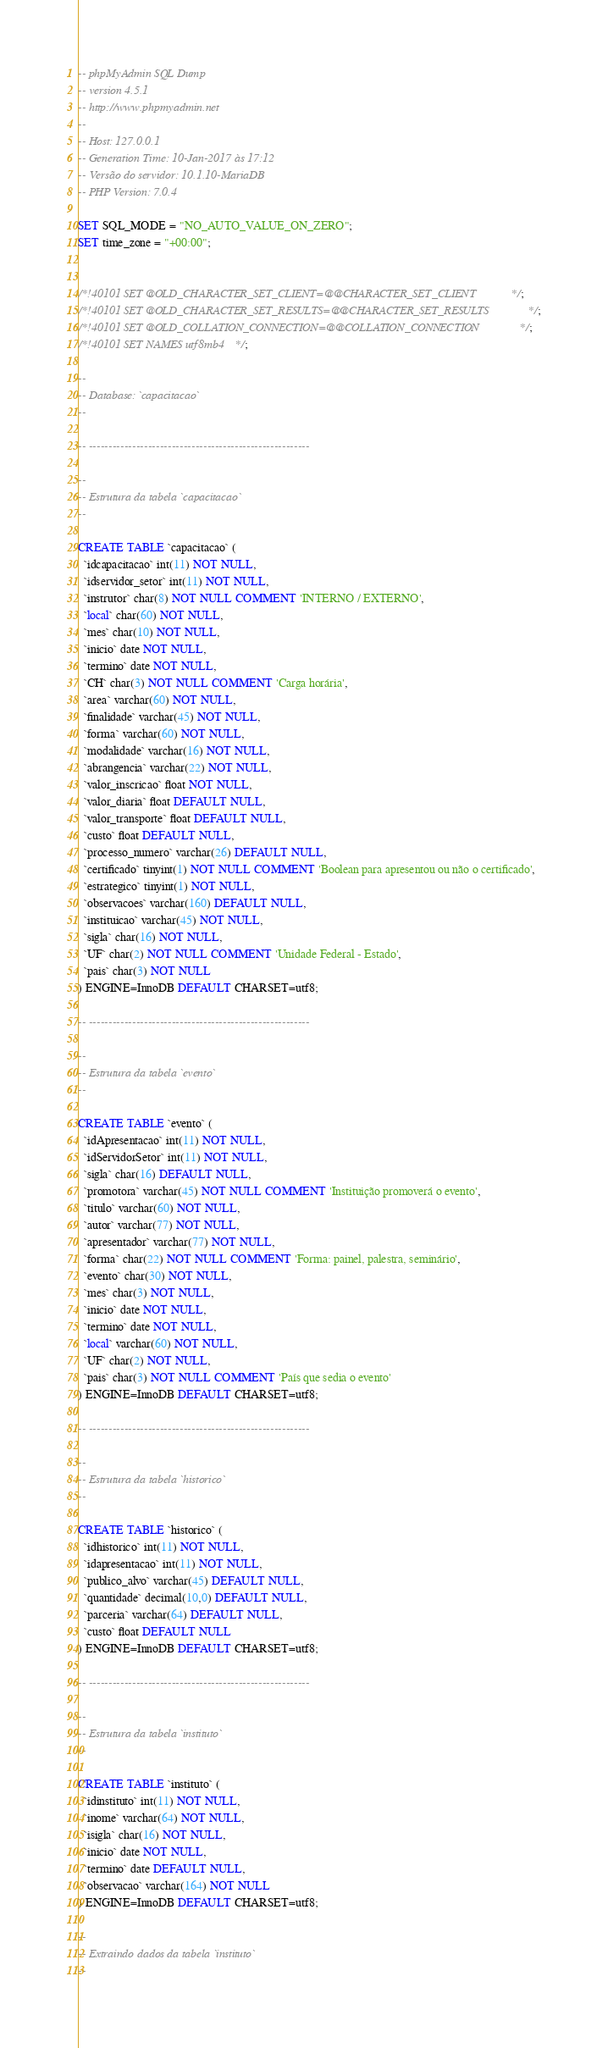<code> <loc_0><loc_0><loc_500><loc_500><_SQL_>-- phpMyAdmin SQL Dump
-- version 4.5.1
-- http://www.phpmyadmin.net
--
-- Host: 127.0.0.1
-- Generation Time: 10-Jan-2017 às 17:12
-- Versão do servidor: 10.1.10-MariaDB
-- PHP Version: 7.0.4

SET SQL_MODE = "NO_AUTO_VALUE_ON_ZERO";
SET time_zone = "+00:00";


/*!40101 SET @OLD_CHARACTER_SET_CLIENT=@@CHARACTER_SET_CLIENT */;
/*!40101 SET @OLD_CHARACTER_SET_RESULTS=@@CHARACTER_SET_RESULTS */;
/*!40101 SET @OLD_COLLATION_CONNECTION=@@COLLATION_CONNECTION */;
/*!40101 SET NAMES utf8mb4 */;

--
-- Database: `capacitacao`
--

-- --------------------------------------------------------

--
-- Estrutura da tabela `capacitacao`
--

CREATE TABLE `capacitacao` (
  `idcapacitacao` int(11) NOT NULL,
  `idservidor_setor` int(11) NOT NULL,
  `instrutor` char(8) NOT NULL COMMENT 'INTERNO / EXTERNO',
  `local` char(60) NOT NULL,
  `mes` char(10) NOT NULL,
  `inicio` date NOT NULL,
  `termino` date NOT NULL,
  `CH` char(3) NOT NULL COMMENT 'Carga horária',
  `area` varchar(60) NOT NULL,
  `finalidade` varchar(45) NOT NULL,
  `forma` varchar(60) NOT NULL,
  `modalidade` varchar(16) NOT NULL,
  `abrangencia` varchar(22) NOT NULL,
  `valor_inscricao` float NOT NULL,
  `valor_diaria` float DEFAULT NULL,
  `valor_transporte` float DEFAULT NULL,
  `custo` float DEFAULT NULL,
  `processo_numero` varchar(26) DEFAULT NULL,
  `certificado` tinyint(1) NOT NULL COMMENT 'Boolean para apresentou ou não o certificado',
  `estrategico` tinyint(1) NOT NULL,
  `observacoes` varchar(160) DEFAULT NULL,
  `instituicao` varchar(45) NOT NULL,
  `sigla` char(16) NOT NULL,
  `UF` char(2) NOT NULL COMMENT 'Unidade Federal - Estado',
  `pais` char(3) NOT NULL
) ENGINE=InnoDB DEFAULT CHARSET=utf8;

-- --------------------------------------------------------

--
-- Estrutura da tabela `evento`
--

CREATE TABLE `evento` (
  `idApresentacao` int(11) NOT NULL,
  `idServidorSetor` int(11) NOT NULL,
  `sigla` char(16) DEFAULT NULL,
  `promotora` varchar(45) NOT NULL COMMENT 'Instituição promoverá o evento',
  `titulo` varchar(60) NOT NULL,
  `autor` varchar(77) NOT NULL,
  `apresentador` varchar(77) NOT NULL,
  `forma` char(22) NOT NULL COMMENT 'Forma: painel, palestra, seminário',
  `evento` char(30) NOT NULL,
  `mes` char(3) NOT NULL,
  `inicio` date NOT NULL,
  `termino` date NOT NULL,
  `local` varchar(60) NOT NULL,
  `UF` char(2) NOT NULL,
  `pais` char(3) NOT NULL COMMENT 'País que sedia o evento'
) ENGINE=InnoDB DEFAULT CHARSET=utf8;

-- --------------------------------------------------------

--
-- Estrutura da tabela `historico`
--

CREATE TABLE `historico` (
  `idhistorico` int(11) NOT NULL,
  `idapresentacao` int(11) NOT NULL,
  `publico_alvo` varchar(45) DEFAULT NULL,
  `quantidade` decimal(10,0) DEFAULT NULL,
  `parceria` varchar(64) DEFAULT NULL,
  `custo` float DEFAULT NULL
) ENGINE=InnoDB DEFAULT CHARSET=utf8;

-- --------------------------------------------------------

--
-- Estrutura da tabela `instituto`
--

CREATE TABLE `instituto` (
  `idinstituto` int(11) NOT NULL,
  `inome` varchar(64) NOT NULL,
  `isigla` char(16) NOT NULL,
  `inicio` date NOT NULL,
  `termino` date DEFAULT NULL,
  `observacao` varchar(164) NOT NULL
) ENGINE=InnoDB DEFAULT CHARSET=utf8;

--
-- Extraindo dados da tabela `instituto`
--
</code> 